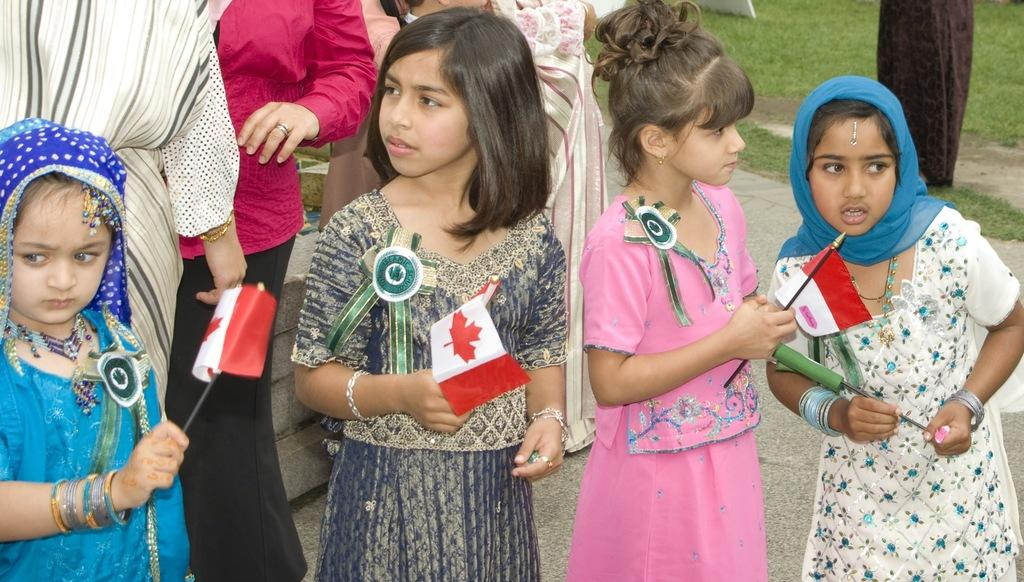How many girls are present in the image? There are four girls in the image. What are the girls holding in their hands? The girls are holding flags in their hands. Are there any other people visible in the image besides the girls? Yes, there are people standing in the image. What type of surface can be seen under the people's feet? There is grass visible in the image. What type of car are the girls driving in the image? There are no cars or driving depicted in the image; the girls are holding flags and standing on grass. 